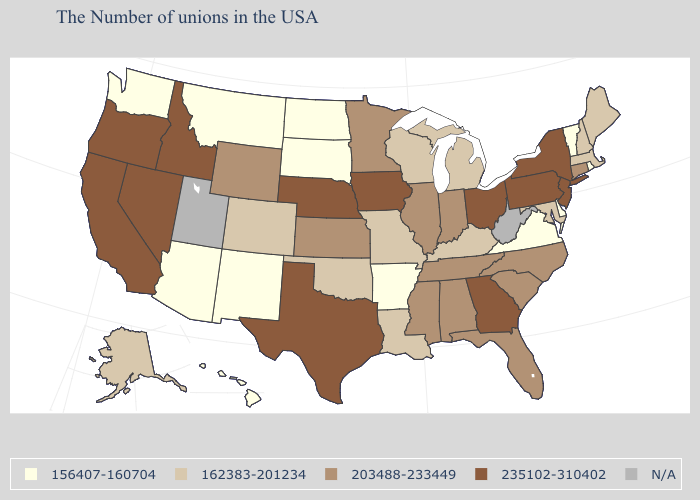Name the states that have a value in the range 203488-233449?
Quick response, please. Connecticut, North Carolina, South Carolina, Florida, Indiana, Alabama, Tennessee, Illinois, Mississippi, Minnesota, Kansas, Wyoming. What is the lowest value in the USA?
Write a very short answer. 156407-160704. Does New Jersey have the highest value in the USA?
Be succinct. Yes. What is the value of Massachusetts?
Answer briefly. 162383-201234. Name the states that have a value in the range 162383-201234?
Be succinct. Maine, Massachusetts, New Hampshire, Maryland, Michigan, Kentucky, Wisconsin, Louisiana, Missouri, Oklahoma, Colorado, Alaska. Name the states that have a value in the range N/A?
Keep it brief. West Virginia, Utah. Which states hav the highest value in the West?
Answer briefly. Idaho, Nevada, California, Oregon. What is the value of Oregon?
Quick response, please. 235102-310402. What is the value of Louisiana?
Keep it brief. 162383-201234. Does Delaware have the lowest value in the USA?
Quick response, please. Yes. Is the legend a continuous bar?
Give a very brief answer. No. What is the value of Idaho?
Concise answer only. 235102-310402. What is the value of North Carolina?
Be succinct. 203488-233449. Name the states that have a value in the range N/A?
Concise answer only. West Virginia, Utah. 